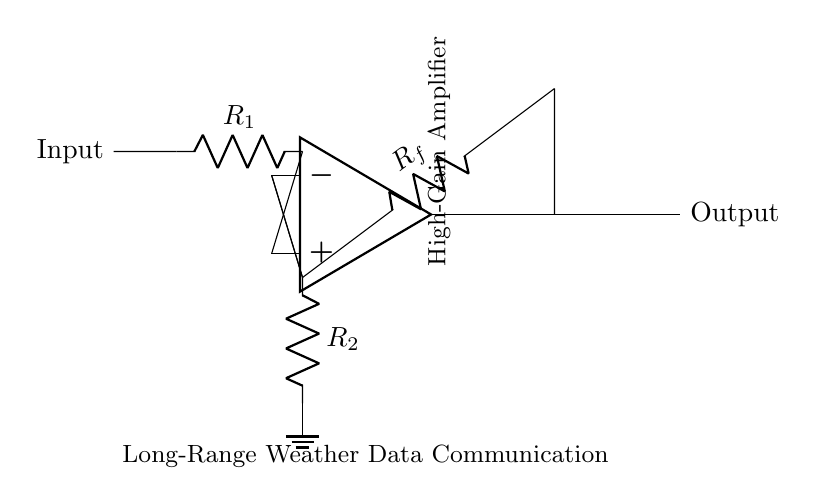What type of amplifier is depicted in the circuit? The diagram shows a high-gain operational amplifier (op-amp) indicated by the label "High-Gain Amplifier."
Answer: High-gain operational amplifier What are the component values of the resistors in this circuit? The resistors are labeled as R1, Rf, and R2, but their specific values are not provided in the diagram. They represent the components essential for setting the gain of the amplifier.
Answer: R1, Rf, R2 What signifies the output of the operational amplifier? The output of the operational amplifier is represented by the line leading away from the op-amp and is specifically labeled "Output."
Answer: Output How does feedback occur in this circuit? Feedback occurs through the resistor Rf, which connects the output of the op-amp back to its inverting input (-), thus creating a feedback loop to control gain.
Answer: Through Rf What is the purpose of the resistor labeled R2? R2 is grounded and serves to set the gain and stabilize the operational amplifier by providing a complete circuit for the inverting input.
Answer: To set gain and stabilize the op-amp What role does the operational amplifier play in this circuit configuration? The operational amplifier amplifies the input signal coming through R1, significantly boosting the signal strength for long-range wireless communication of weather data.
Answer: Amplification of input signal What application is this circuit primarily designed for? The circuit is designed for long-range weather data communication, as indicated by the label "Long-Range Weather Data Communication" in the diagram.
Answer: Long-range weather data communication 